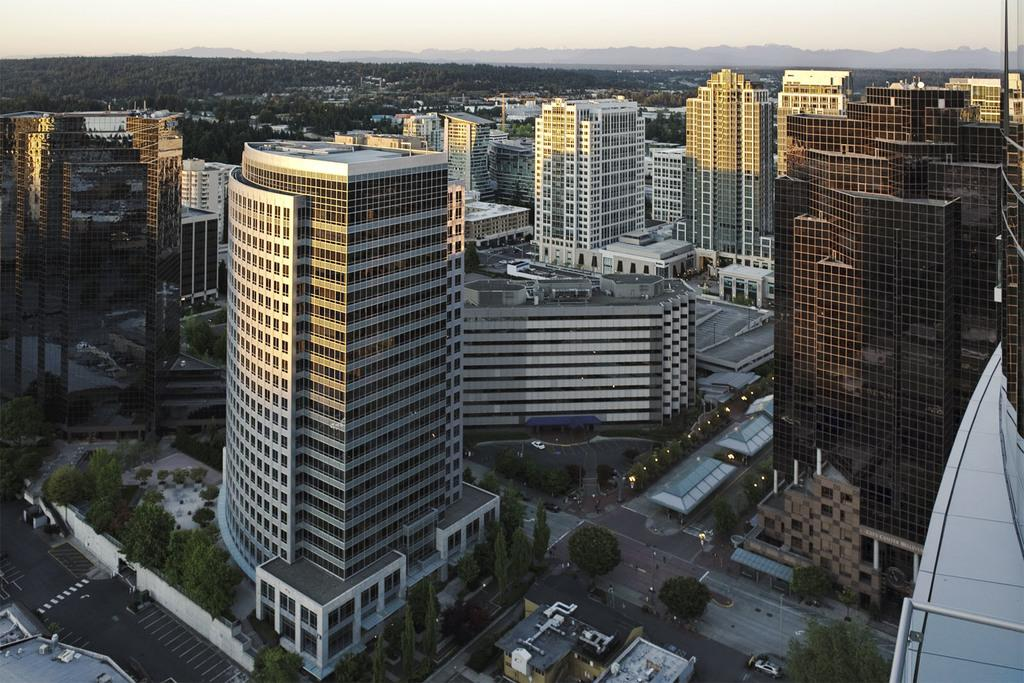What can be seen on the road in the image? There are vehicles on the road in the image. What type of natural elements can be seen in the background of the image? There are trees and hills visible in the background of the image. What type of man-made structures can be seen in the background of the image? There are buildings in the background of the image. What is visible at the top of the image? The sky is visible at the top of the image. How many brass cats are sitting on the board in the image? There are no brass cats or boards present in the image. What type of board is being used by the vehicles on the road? The image does not show any boards being used by the vehicles; they are simply driving on the road. 